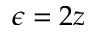<formula> <loc_0><loc_0><loc_500><loc_500>\epsilon = 2 z</formula> 